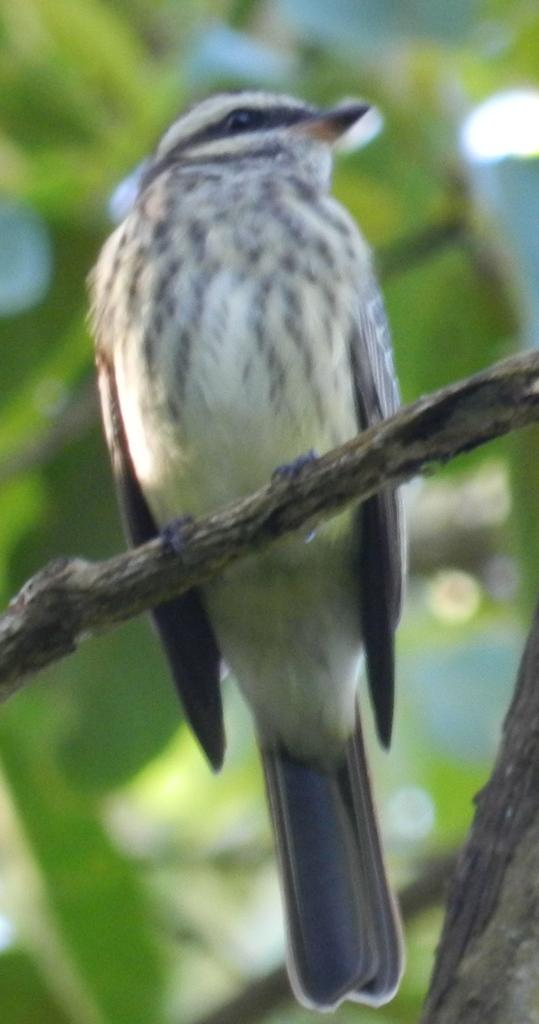What type of animal is in the image? There is a bird in the image. Where is the bird located? The bird is standing on a branch. What is the branch a part of? The branch is part of a tree. Can you describe the background of the image? The background of the image is blurred. What type of account does the bird have in the image? There is no mention of an account in the image, as it features a bird standing on a branch. 